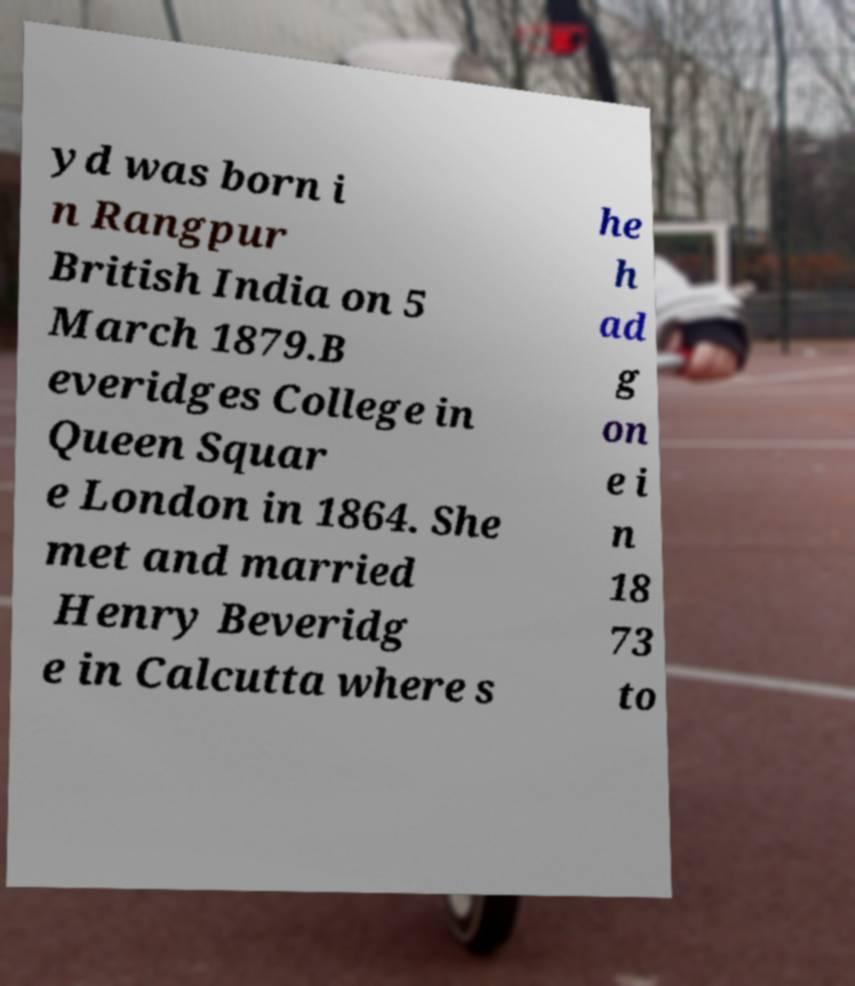For documentation purposes, I need the text within this image transcribed. Could you provide that? yd was born i n Rangpur British India on 5 March 1879.B everidges College in Queen Squar e London in 1864. She met and married Henry Beveridg e in Calcutta where s he h ad g on e i n 18 73 to 